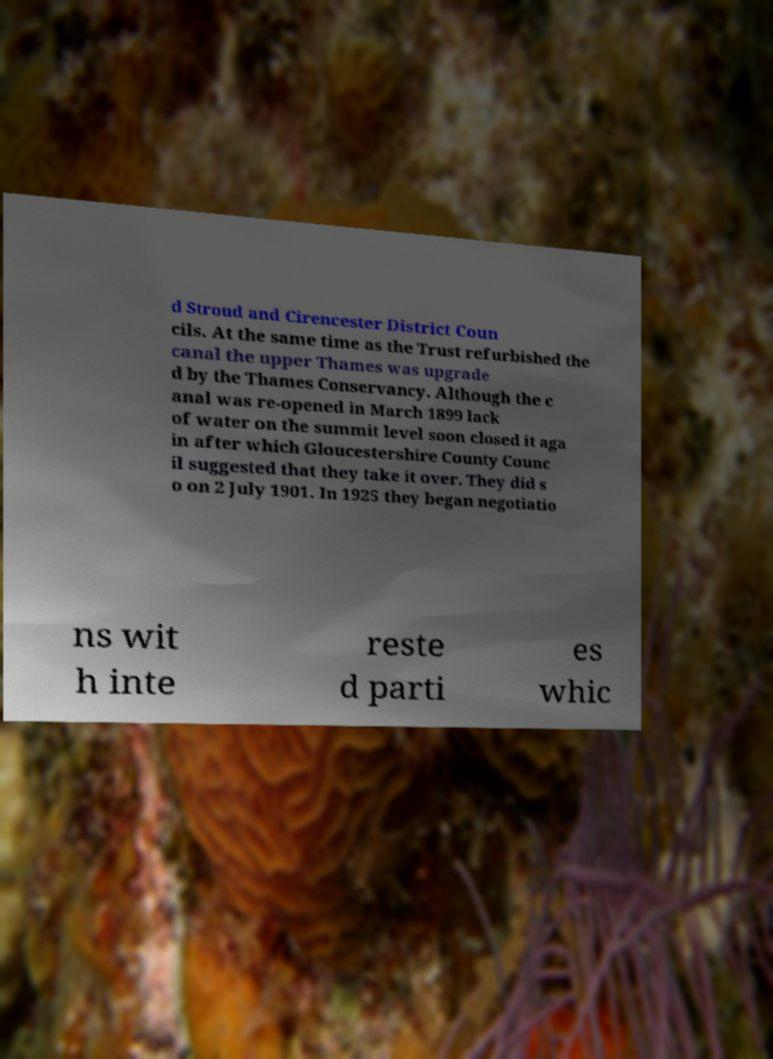Please read and relay the text visible in this image. What does it say? d Stroud and Cirencester District Coun cils. At the same time as the Trust refurbished the canal the upper Thames was upgrade d by the Thames Conservancy. Although the c anal was re-opened in March 1899 lack of water on the summit level soon closed it aga in after which Gloucestershire County Counc il suggested that they take it over. They did s o on 2 July 1901. In 1925 they began negotiatio ns wit h inte reste d parti es whic 